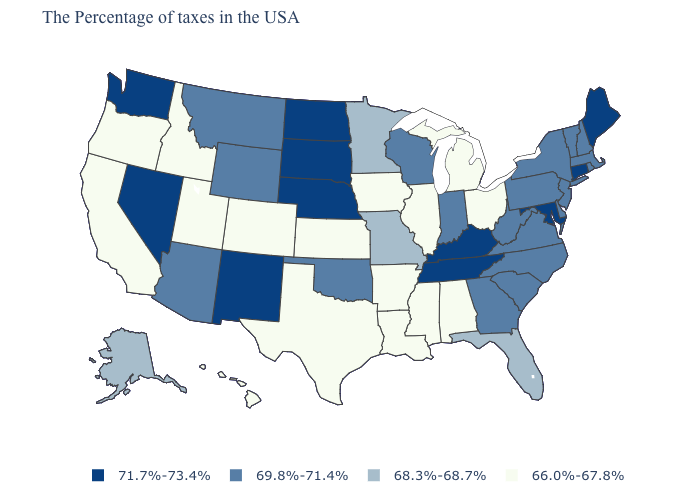Name the states that have a value in the range 68.3%-68.7%?
Short answer required. Florida, Missouri, Minnesota, Alaska. Does Washington have the highest value in the USA?
Concise answer only. Yes. Does the first symbol in the legend represent the smallest category?
Concise answer only. No. Among the states that border Colorado , which have the lowest value?
Write a very short answer. Kansas, Utah. Does the map have missing data?
Short answer required. No. What is the value of Maryland?
Concise answer only. 71.7%-73.4%. What is the value of Arkansas?
Keep it brief. 66.0%-67.8%. Name the states that have a value in the range 71.7%-73.4%?
Quick response, please. Maine, Connecticut, Maryland, Kentucky, Tennessee, Nebraska, South Dakota, North Dakota, New Mexico, Nevada, Washington. Does Nevada have the same value as New Mexico?
Answer briefly. Yes. Does Alabama have the lowest value in the South?
Keep it brief. Yes. Among the states that border Arkansas , which have the highest value?
Concise answer only. Tennessee. Name the states that have a value in the range 71.7%-73.4%?
Give a very brief answer. Maine, Connecticut, Maryland, Kentucky, Tennessee, Nebraska, South Dakota, North Dakota, New Mexico, Nevada, Washington. What is the lowest value in states that border New Hampshire?
Keep it brief. 69.8%-71.4%. Name the states that have a value in the range 71.7%-73.4%?
Answer briefly. Maine, Connecticut, Maryland, Kentucky, Tennessee, Nebraska, South Dakota, North Dakota, New Mexico, Nevada, Washington. Name the states that have a value in the range 71.7%-73.4%?
Be succinct. Maine, Connecticut, Maryland, Kentucky, Tennessee, Nebraska, South Dakota, North Dakota, New Mexico, Nevada, Washington. 